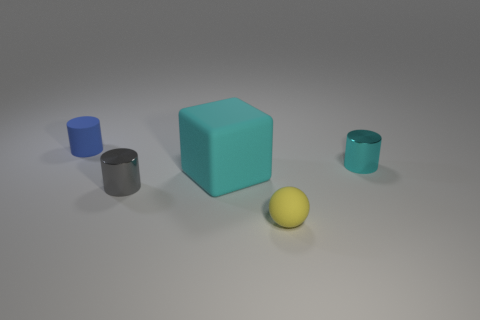There is a cylinder that is the same color as the big thing; what is its size?
Keep it short and to the point. Small. Does the matte sphere have the same size as the gray object?
Provide a short and direct response. Yes. Is the number of small objects to the right of the tiny yellow sphere greater than the number of rubber cubes in front of the gray object?
Make the answer very short. Yes. How many other objects are there of the same size as the yellow rubber ball?
Your answer should be compact. 3. There is a tiny metallic cylinder to the right of the gray metallic cylinder; is it the same color as the rubber block?
Offer a terse response. Yes. Are there more shiny cylinders left of the matte sphere than tiny gray spheres?
Keep it short and to the point. Yes. Is there any other thing that is the same color as the large matte cube?
Make the answer very short. Yes. There is a cyan thing left of the tiny object in front of the tiny gray thing; what shape is it?
Provide a succinct answer. Cube. Are there more tiny balls than objects?
Provide a succinct answer. No. What number of tiny objects are both to the right of the tiny gray metal cylinder and behind the large object?
Your answer should be compact. 1. 